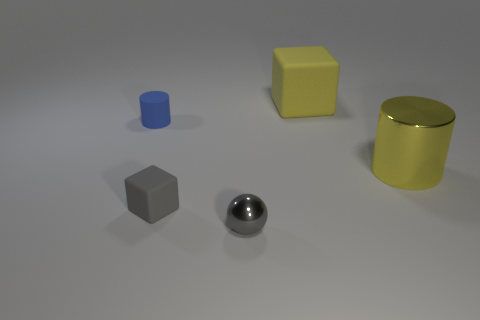Add 1 small red rubber cylinders. How many objects exist? 6 Subtract all gray blocks. How many blocks are left? 1 Subtract all cylinders. How many objects are left? 3 Add 1 big yellow cylinders. How many big yellow cylinders exist? 2 Subtract 0 cyan spheres. How many objects are left? 5 Subtract all big objects. Subtract all small blue rubber objects. How many objects are left? 2 Add 4 small gray things. How many small gray things are left? 6 